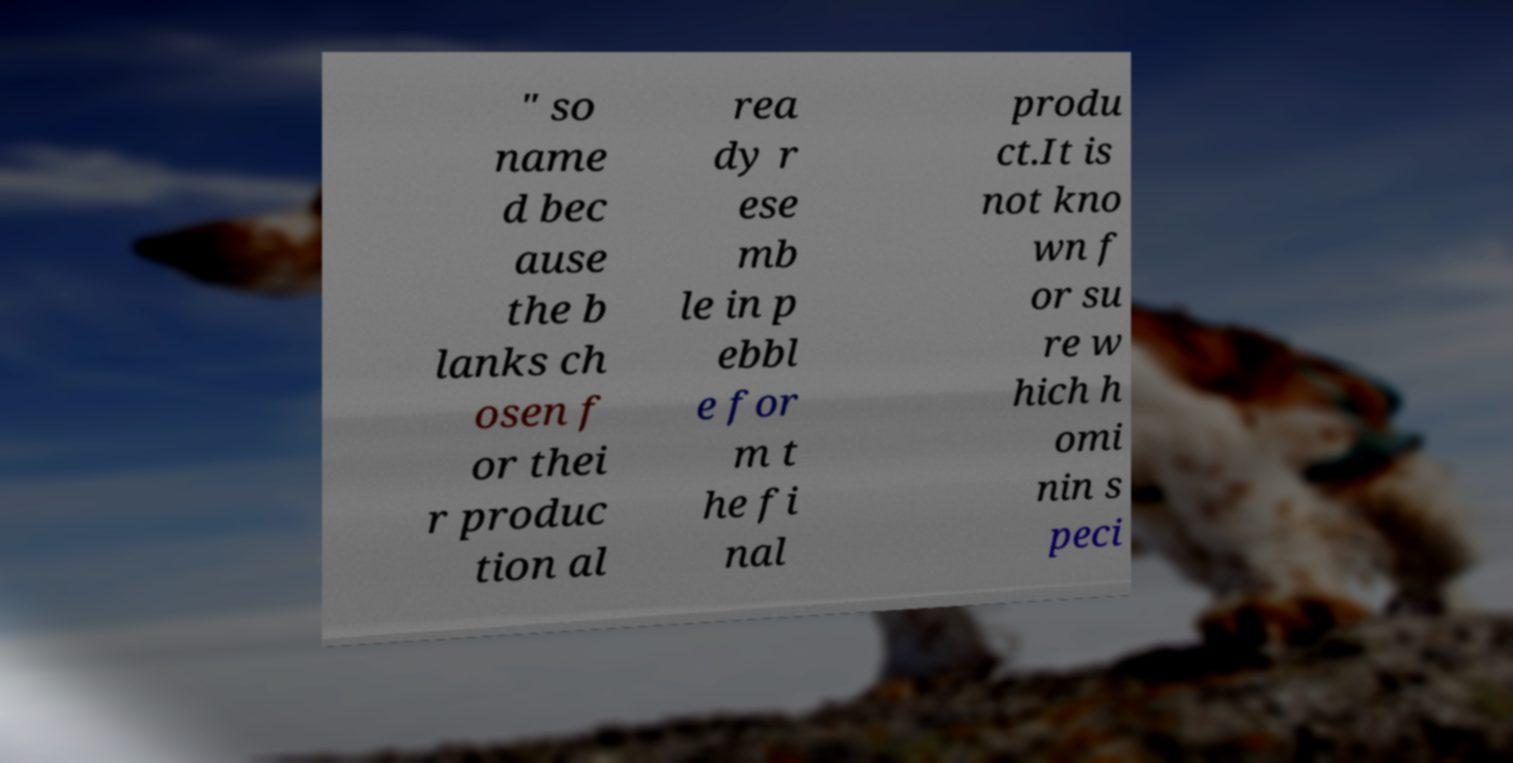Please read and relay the text visible in this image. What does it say? " so name d bec ause the b lanks ch osen f or thei r produc tion al rea dy r ese mb le in p ebbl e for m t he fi nal produ ct.It is not kno wn f or su re w hich h omi nin s peci 